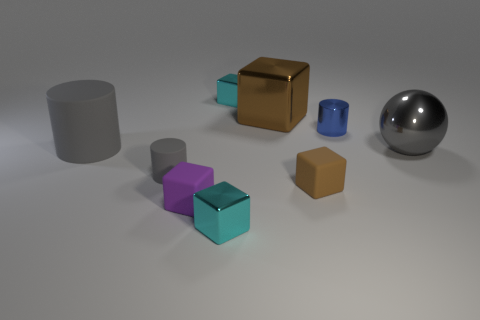Does the large gray ball have the same material as the tiny cylinder to the left of the tiny purple matte object?
Provide a succinct answer. No. Are there any things of the same color as the big metallic ball?
Provide a short and direct response. Yes. There is a gray object behind the gray metallic thing; what number of small metallic objects are in front of it?
Your response must be concise. 1. Is the material of the large gray object that is left of the sphere the same as the large sphere?
Keep it short and to the point. No. Are the cyan object behind the tiny brown matte cube and the small cyan object in front of the purple cube made of the same material?
Ensure brevity in your answer.  Yes. Are there more gray objects that are on the left side of the metal cylinder than tiny blocks?
Provide a succinct answer. No. The big object to the right of the tiny cylinder that is behind the large ball is what color?
Provide a short and direct response. Gray. There is another gray thing that is the same size as the gray metal object; what is its shape?
Make the answer very short. Cylinder. What shape is the small matte object that is the same color as the large matte object?
Your response must be concise. Cylinder. Are there the same number of cyan shiny things that are in front of the small brown rubber object and large yellow matte balls?
Ensure brevity in your answer.  No. 